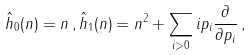Convert formula to latex. <formula><loc_0><loc_0><loc_500><loc_500>{ \hat { h } } _ { 0 } ( n ) = n \, , { \hat { h } } _ { 1 } ( n ) = n ^ { 2 } + \sum _ { i > 0 } i p _ { i } \frac { \partial } { \partial p _ { i } } \, ,</formula> 